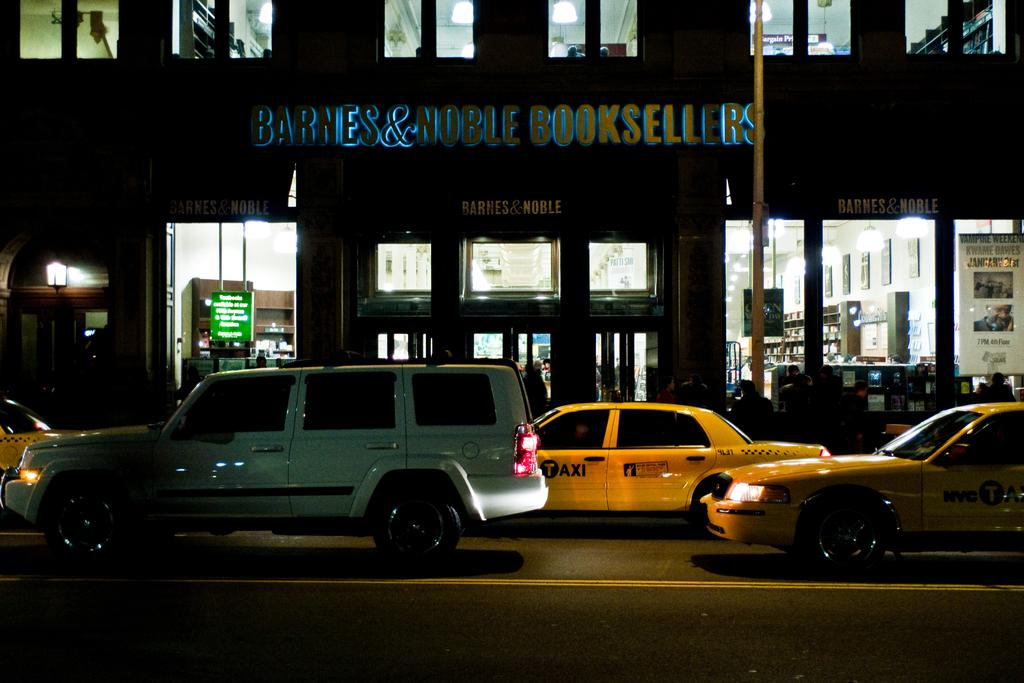Provide a one-sentence caption for the provided image. Traffic on the city streets outside of a Barnes & Noble Booksellers store. 